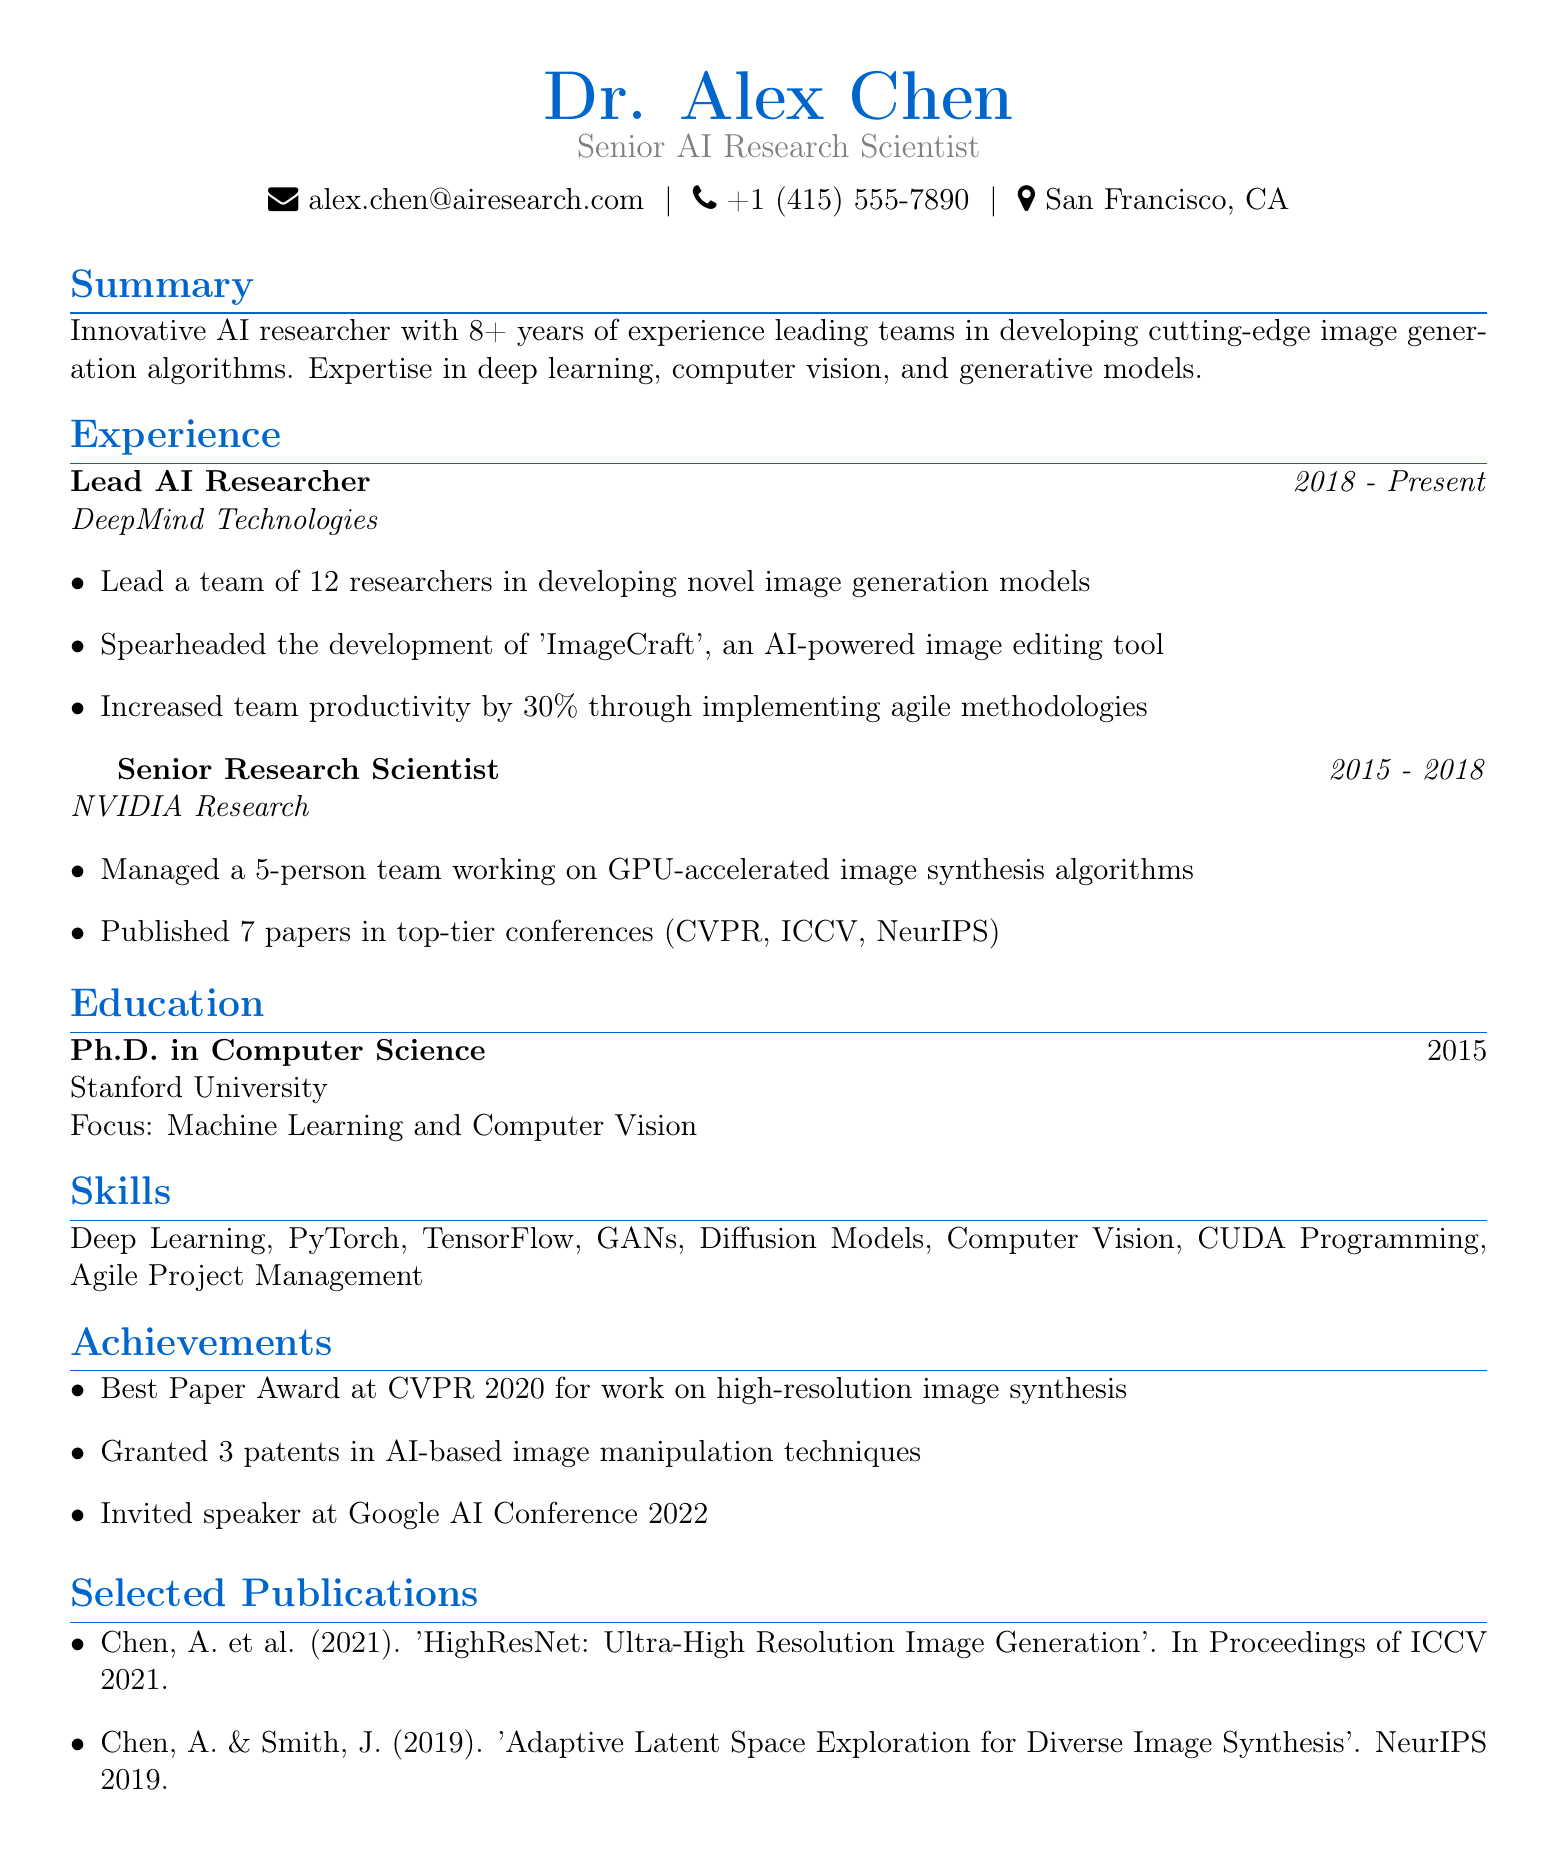What is the current title of Dr. Alex Chen? The document states that Dr. Alex Chen's current title is "Senior AI Research Scientist."
Answer: Senior AI Research Scientist How many years of experience does Dr. Alex Chen have? The summary mentions that Dr. Alex Chen has over 8 years of experience in AI research.
Answer: 8+ Which company has Dr. Alex Chen been with since 2018? The experience section indicates that Dr. Alex Chen has been with DeepMind Technologies since 2018.
Answer: DeepMind Technologies What was a significant achievement during Dr. Alex Chen's tenure at CVPR 2020? The achievements list includes that Dr. Alex Chen received the "Best Paper Award at CVPR 2020."
Answer: Best Paper Award at CVPR 2020 How many patents has Dr. Alex Chen been granted? The achievements section states that Dr. Alex Chen has been granted 3 patents.
Answer: 3 patents What is the focus of Dr. Alex Chen's Ph.D. degree? The education section outlines that the focus of Dr. Alex Chen's Ph.D. is in "Machine Learning and Computer Vision."
Answer: Machine Learning and Computer Vision How many papers did Dr. Alex Chen publish at top-tier conferences while at NVIDIA? According to the experience section, Dr. Alex Chen published 7 papers at top-tier conferences.
Answer: 7 papers What position did Dr. Alex Chen hold before becoming a Lead AI Researcher? The experience section indicates that Dr. Alex Chen was a "Senior Research Scientist" before his current position.
Answer: Senior Research Scientist What productivity improvement percentage did Dr. Alex Chen achieve at DeepMind? The responsibilities at DeepMind signify a 30% increase in team productivity.
Answer: 30% 